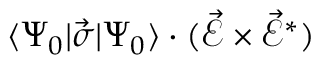Convert formula to latex. <formula><loc_0><loc_0><loc_500><loc_500>\langle \Psi _ { 0 } | \vec { \sigma } | \Psi _ { 0 } \rangle \cdot ( \vec { \mathcal { E } } \times \vec { \mathcal { E } } ^ { \ast } )</formula> 